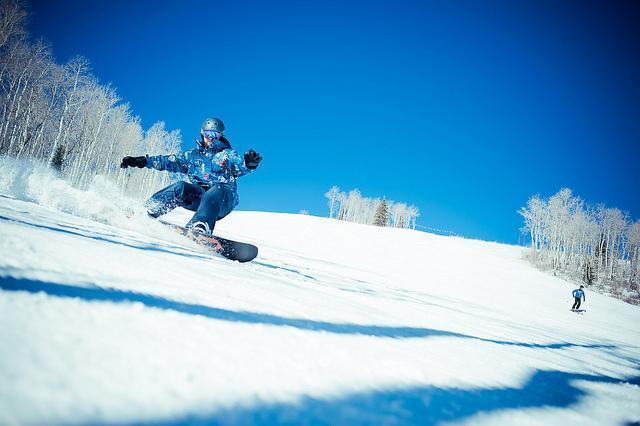In which direction is this snowboarder moving?
Make your selection and explain in format: 'Answer: answer
Rationale: rationale.'
Options: Left, away, towards, right. Answer: right.
Rationale: The snowboarder seems to be going on the right. 